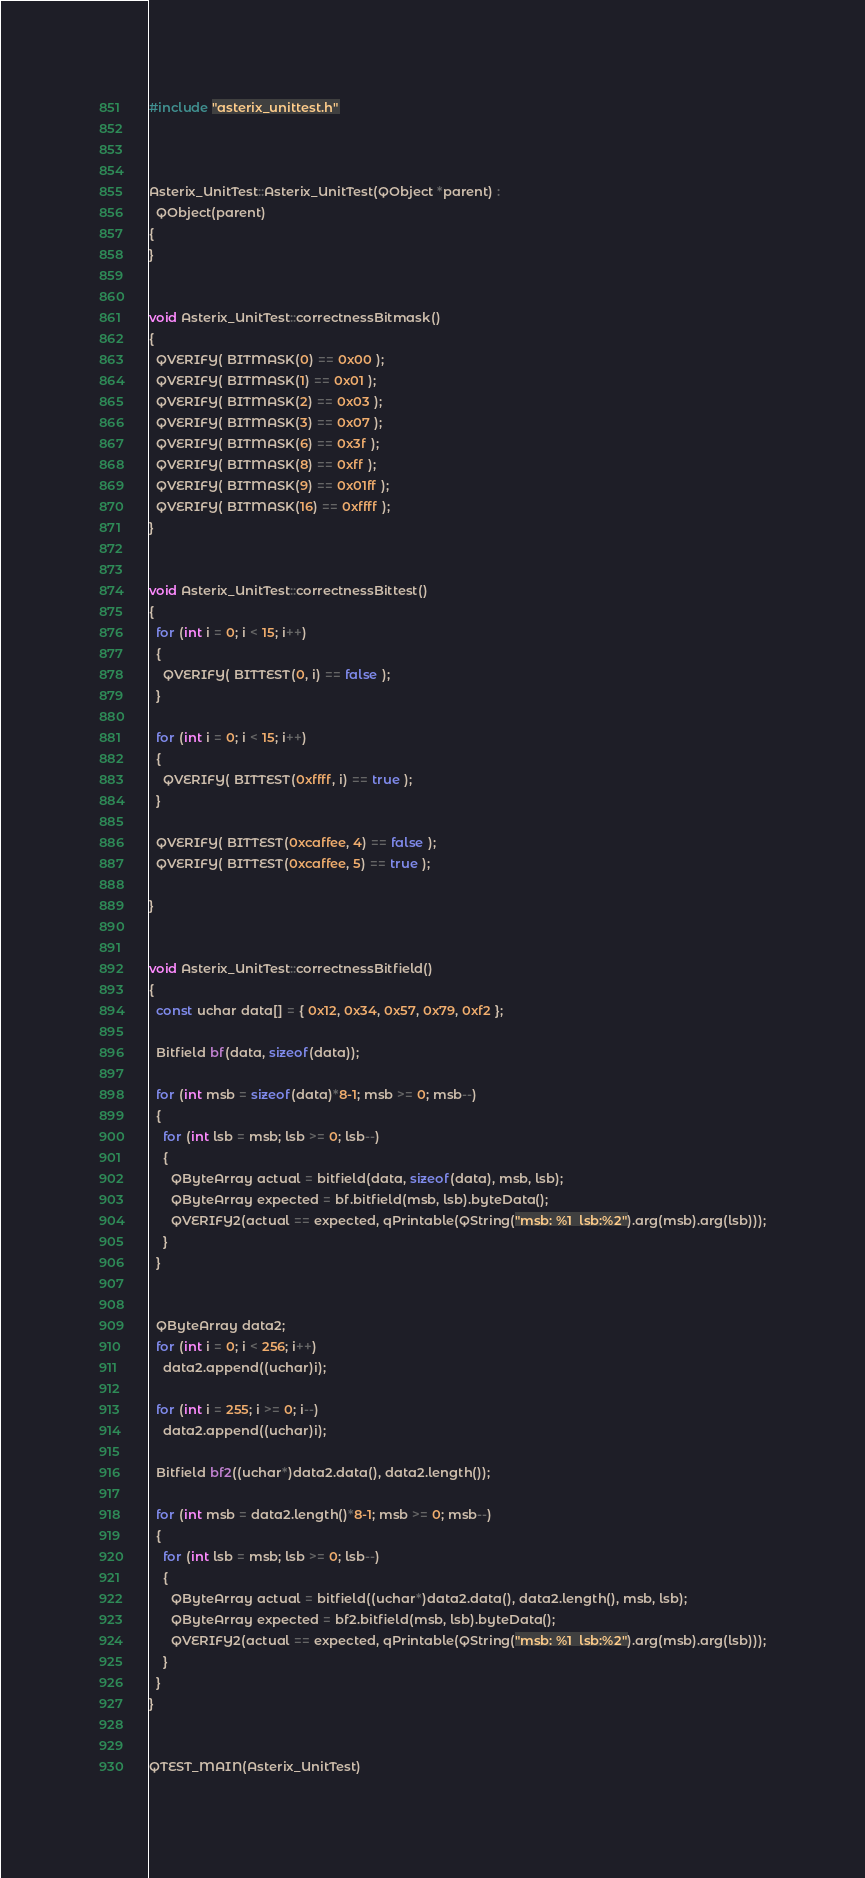Convert code to text. <code><loc_0><loc_0><loc_500><loc_500><_C++_>
#include "asterix_unittest.h"



Asterix_UnitTest::Asterix_UnitTest(QObject *parent) :
  QObject(parent)
{
}


void Asterix_UnitTest::correctnessBitmask()
{
  QVERIFY( BITMASK(0) == 0x00 );
  QVERIFY( BITMASK(1) == 0x01 );
  QVERIFY( BITMASK(2) == 0x03 );
  QVERIFY( BITMASK(3) == 0x07 );
  QVERIFY( BITMASK(6) == 0x3f );
  QVERIFY( BITMASK(8) == 0xff );
  QVERIFY( BITMASK(9) == 0x01ff );
  QVERIFY( BITMASK(16) == 0xffff );
}


void Asterix_UnitTest::correctnessBittest()
{
  for (int i = 0; i < 15; i++)
  {
    QVERIFY( BITTEST(0, i) == false );
  }
 
  for (int i = 0; i < 15; i++)
  {
    QVERIFY( BITTEST(0xffff, i) == true );
  }

  QVERIFY( BITTEST(0xcaffee, 4) == false );
  QVERIFY( BITTEST(0xcaffee, 5) == true );
  
}


void Asterix_UnitTest::correctnessBitfield()
{
  const uchar data[] = { 0x12, 0x34, 0x57, 0x79, 0xf2 };

  Bitfield bf(data, sizeof(data));

  for (int msb = sizeof(data)*8-1; msb >= 0; msb--)
  {
    for (int lsb = msb; lsb >= 0; lsb--)
    {
      QByteArray actual = bitfield(data, sizeof(data), msb, lsb);
      QByteArray expected = bf.bitfield(msb, lsb).byteData();
      QVERIFY2(actual == expected, qPrintable(QString("msb: %1  lsb:%2").arg(msb).arg(lsb)));
    }
  }


  QByteArray data2;
  for (int i = 0; i < 256; i++)
    data2.append((uchar)i);
    
  for (int i = 255; i >= 0; i--)
    data2.append((uchar)i);

  Bitfield bf2((uchar*)data2.data(), data2.length());

  for (int msb = data2.length()*8-1; msb >= 0; msb--)
  {
    for (int lsb = msb; lsb >= 0; lsb--)
    {
      QByteArray actual = bitfield((uchar*)data2.data(), data2.length(), msb, lsb);
      QByteArray expected = bf2.bitfield(msb, lsb).byteData();
      QVERIFY2(actual == expected, qPrintable(QString("msb: %1  lsb:%2").arg(msb).arg(lsb)));
    }
  }
}


QTEST_MAIN(Asterix_UnitTest)

</code> 